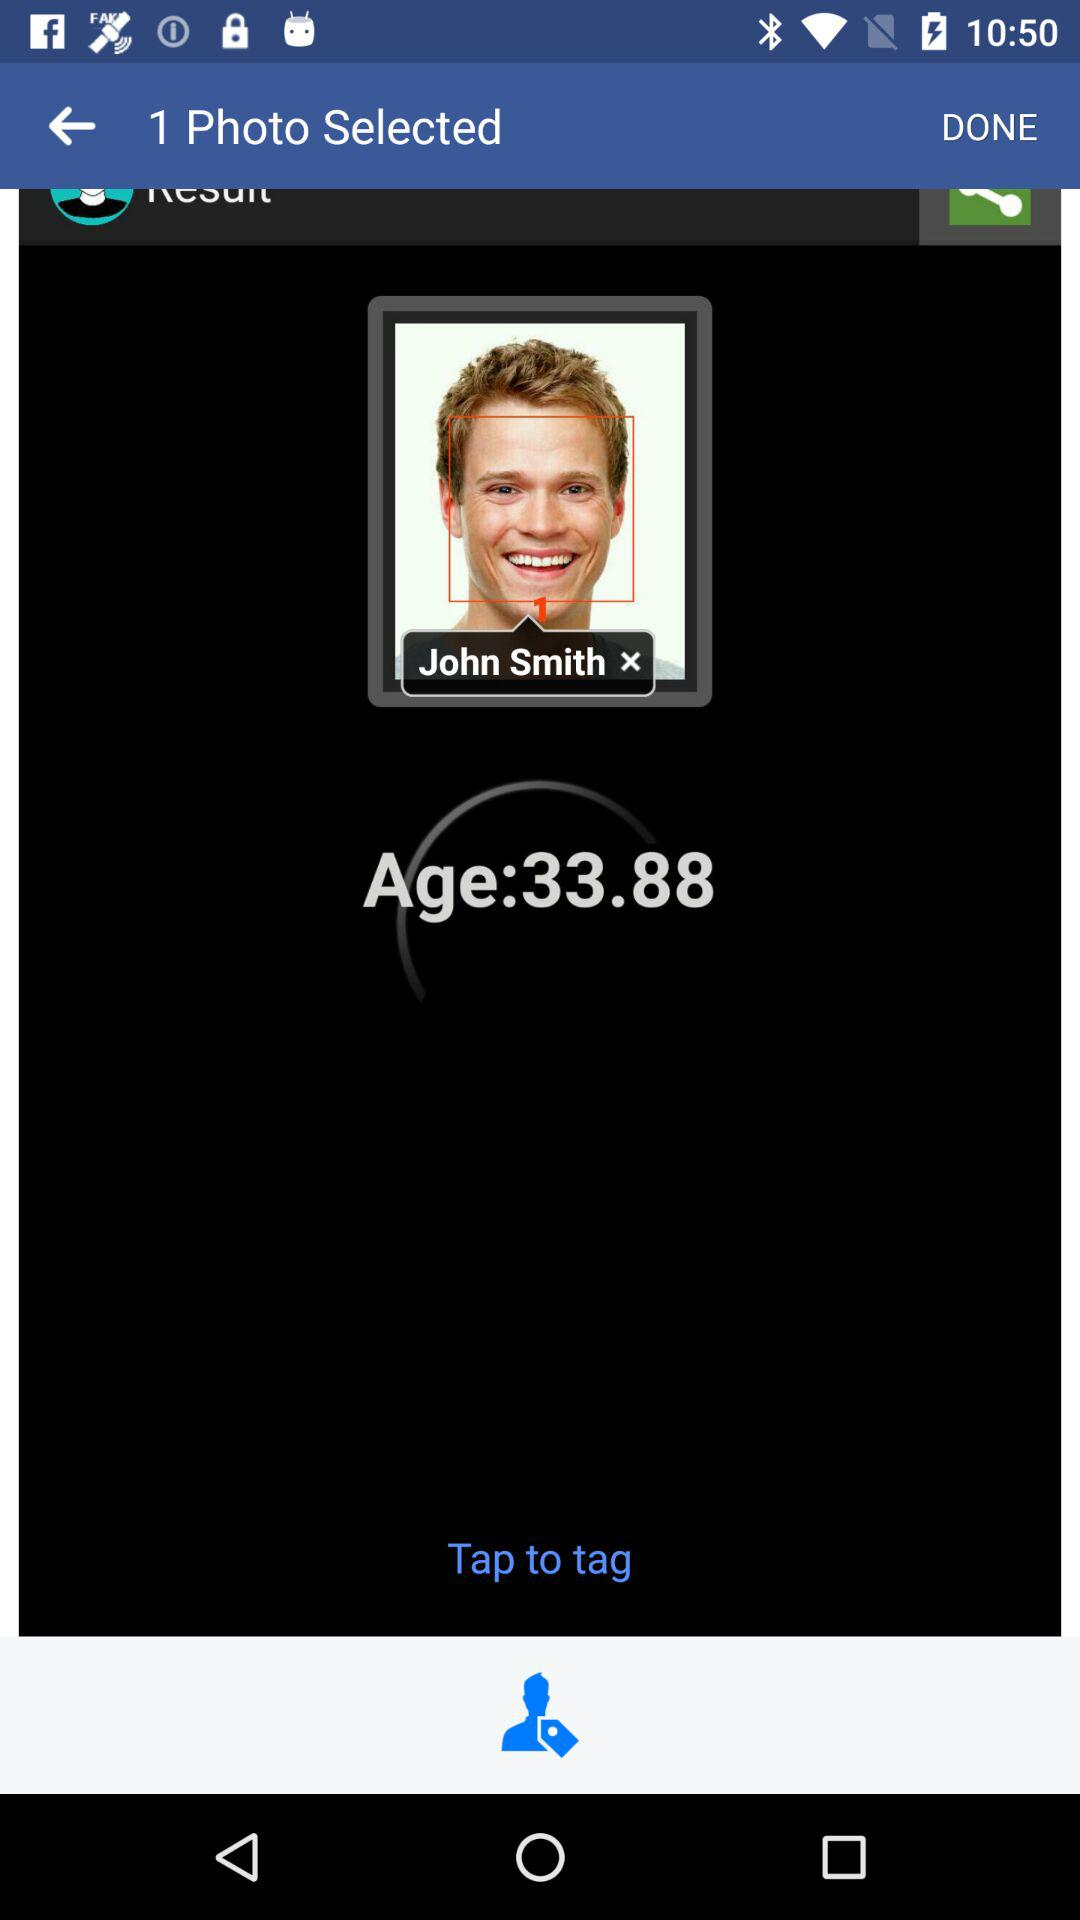What is the name of the user? The name of the user is John Smith. 